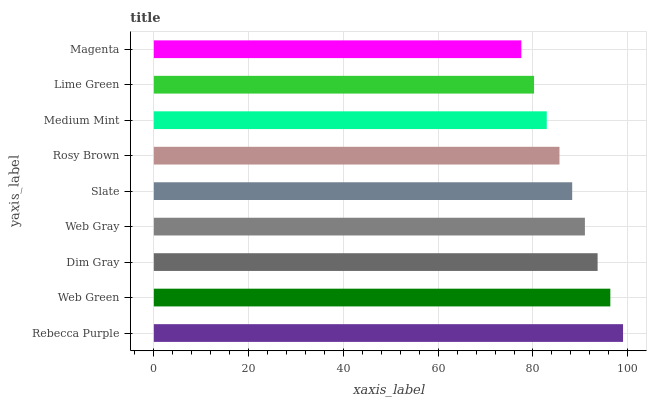Is Magenta the minimum?
Answer yes or no. Yes. Is Rebecca Purple the maximum?
Answer yes or no. Yes. Is Web Green the minimum?
Answer yes or no. No. Is Web Green the maximum?
Answer yes or no. No. Is Rebecca Purple greater than Web Green?
Answer yes or no. Yes. Is Web Green less than Rebecca Purple?
Answer yes or no. Yes. Is Web Green greater than Rebecca Purple?
Answer yes or no. No. Is Rebecca Purple less than Web Green?
Answer yes or no. No. Is Slate the high median?
Answer yes or no. Yes. Is Slate the low median?
Answer yes or no. Yes. Is Magenta the high median?
Answer yes or no. No. Is Rosy Brown the low median?
Answer yes or no. No. 